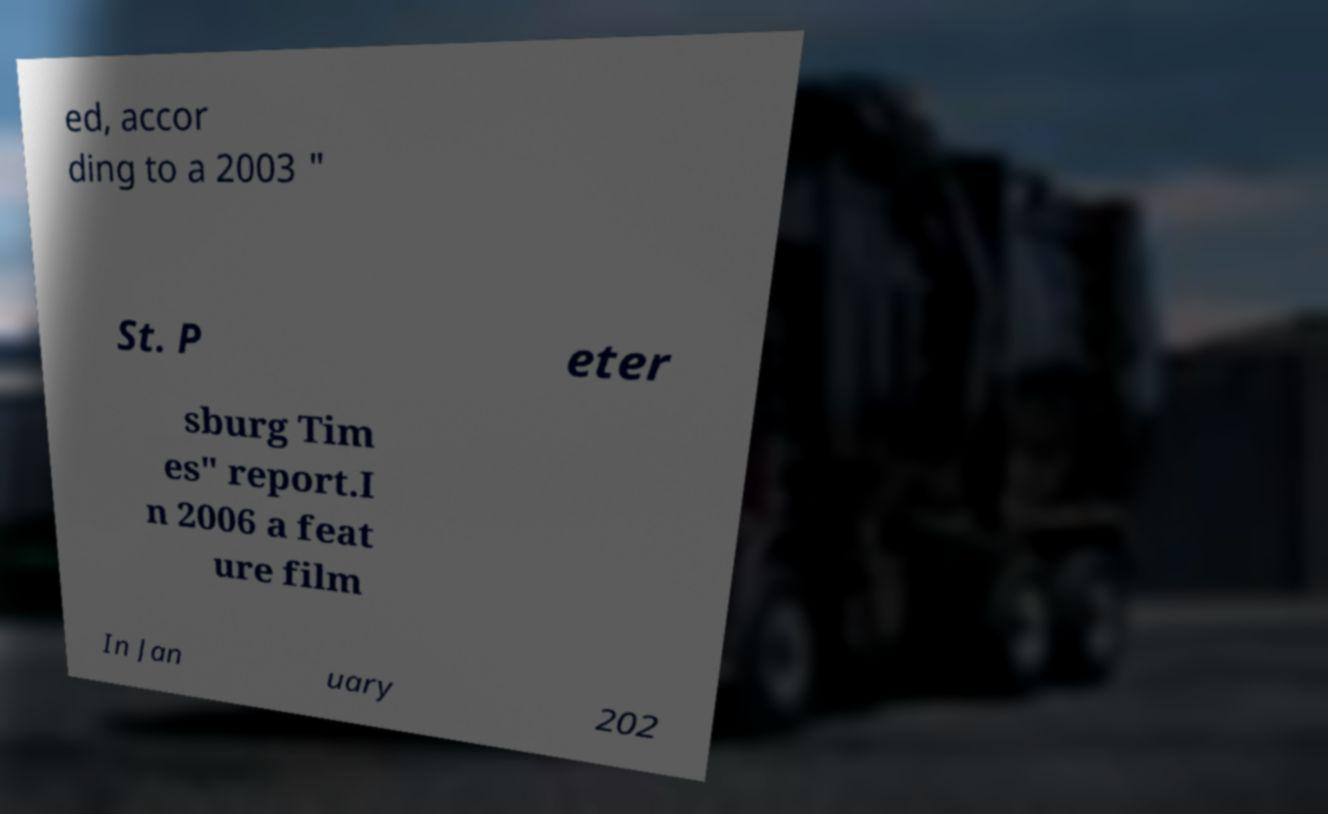For documentation purposes, I need the text within this image transcribed. Could you provide that? ed, accor ding to a 2003 " St. P eter sburg Tim es" report.I n 2006 a feat ure film In Jan uary 202 